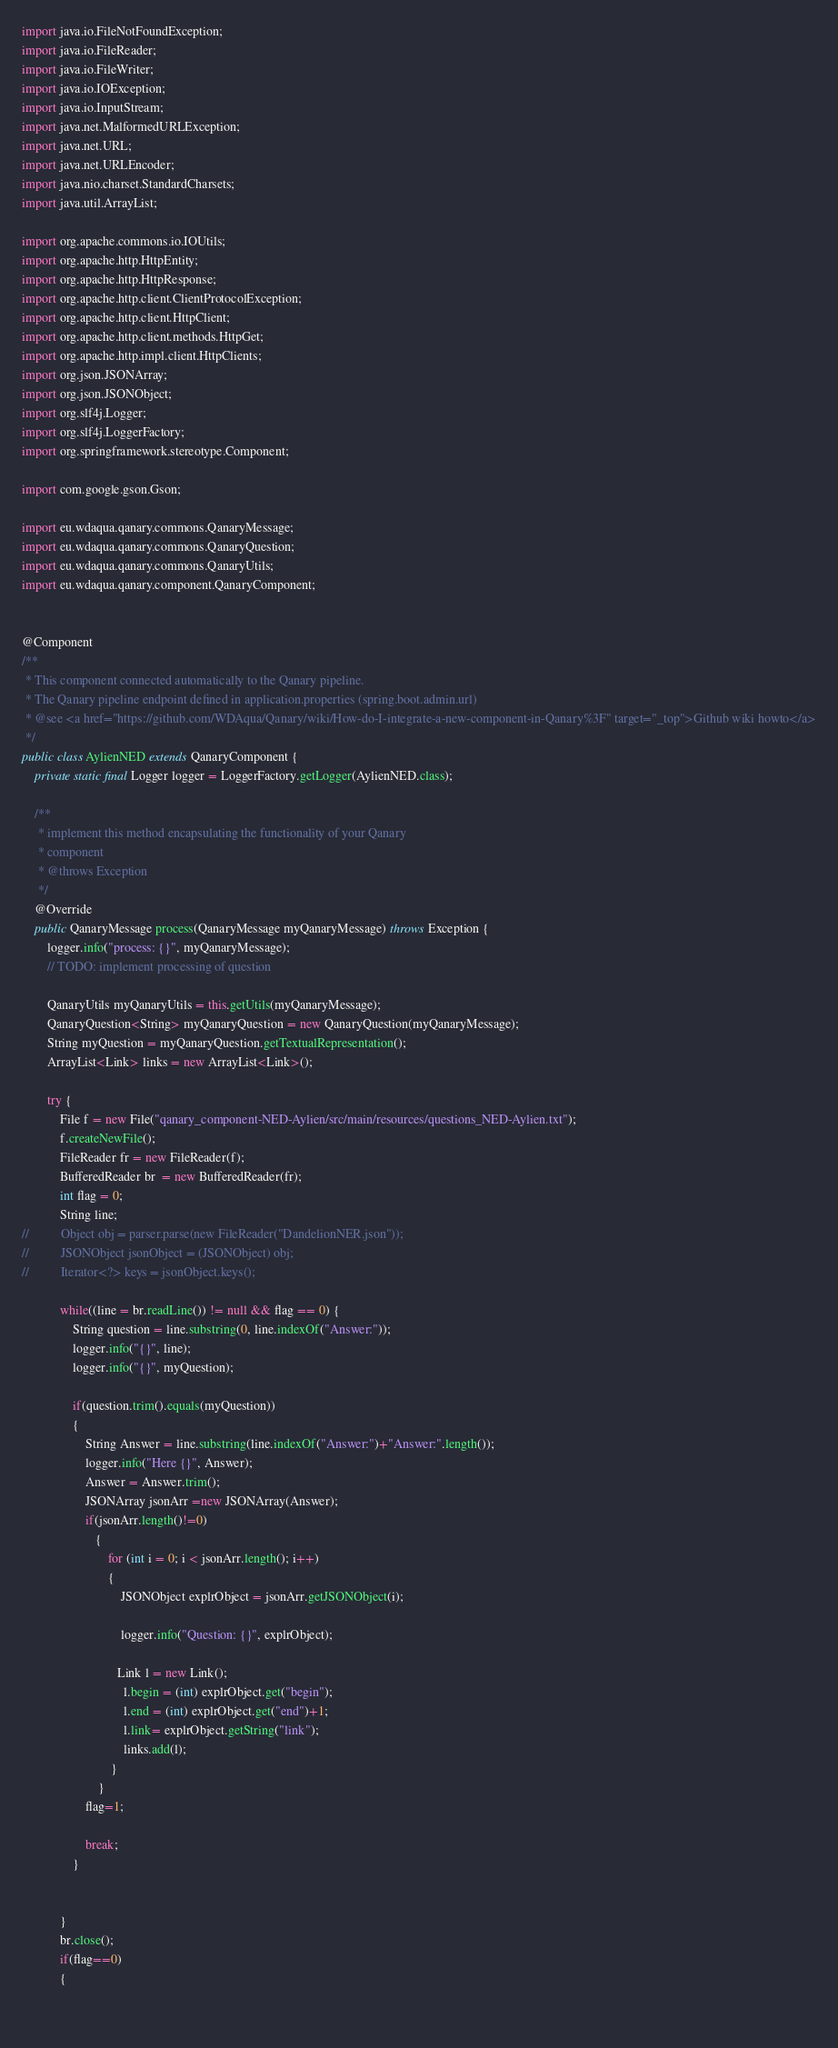<code> <loc_0><loc_0><loc_500><loc_500><_Java_>import java.io.FileNotFoundException;
import java.io.FileReader;
import java.io.FileWriter;
import java.io.IOException;
import java.io.InputStream;
import java.net.MalformedURLException;
import java.net.URL;
import java.net.URLEncoder;
import java.nio.charset.StandardCharsets;
import java.util.ArrayList;

import org.apache.commons.io.IOUtils;
import org.apache.http.HttpEntity;
import org.apache.http.HttpResponse;
import org.apache.http.client.ClientProtocolException;
import org.apache.http.client.HttpClient;
import org.apache.http.client.methods.HttpGet;
import org.apache.http.impl.client.HttpClients;
import org.json.JSONArray;
import org.json.JSONObject;
import org.slf4j.Logger;
import org.slf4j.LoggerFactory;
import org.springframework.stereotype.Component;

import com.google.gson.Gson;

import eu.wdaqua.qanary.commons.QanaryMessage;
import eu.wdaqua.qanary.commons.QanaryQuestion;
import eu.wdaqua.qanary.commons.QanaryUtils;
import eu.wdaqua.qanary.component.QanaryComponent;


@Component
/**
 * This component connected automatically to the Qanary pipeline.
 * The Qanary pipeline endpoint defined in application.properties (spring.boot.admin.url)
 * @see <a href="https://github.com/WDAqua/Qanary/wiki/How-do-I-integrate-a-new-component-in-Qanary%3F" target="_top">Github wiki howto</a>
 */
public class AylienNED extends QanaryComponent {
	private static final Logger logger = LoggerFactory.getLogger(AylienNED.class);

	/**
	 * implement this method encapsulating the functionality of your Qanary
	 * component
	 * @throws Exception 
	 */
	@Override
	public QanaryMessage process(QanaryMessage myQanaryMessage) throws Exception {
		logger.info("process: {}", myQanaryMessage);
		// TODO: implement processing of question
		
		QanaryUtils myQanaryUtils = this.getUtils(myQanaryMessage);
	    QanaryQuestion<String> myQanaryQuestion = new QanaryQuestion(myQanaryMessage);
	    String myQuestion = myQanaryQuestion.getTextualRepresentation();
	    ArrayList<Link> links = new ArrayList<Link>();
	    
	    try {
			File f = new File("qanary_component-NED-Aylien/src/main/resources/questions_NED-Aylien.txt");
			f.createNewFile(); 
	    	FileReader fr = new FileReader(f);
	    	BufferedReader br  = new BufferedReader(fr);
			int flag = 0;
			String line;
//			Object obj = parser.parse(new FileReader("DandelionNER.json"));
//			JSONObject jsonObject = (JSONObject) obj;
//			Iterator<?> keys = jsonObject.keys();
			
			while((line = br.readLine()) != null && flag == 0) {
			    String question = line.substring(0, line.indexOf("Answer:"));
				logger.info("{}", line);
				logger.info("{}", myQuestion);
				
			    if(question.trim().equals(myQuestion))
			    {
			    	String Answer = line.substring(line.indexOf("Answer:")+"Answer:".length());
			    	logger.info("Here {}", Answer);
			    	Answer = Answer.trim();
			    	JSONArray jsonArr =new JSONArray(Answer);
			    	if(jsonArr.length()!=0)
	 	        	   {
	 	        		   for (int i = 0; i < jsonArr.length(); i++) 
	 	        		   {
	 	        			   JSONObject explrObject = jsonArr.getJSONObject(i);
	 	        			  
	 	        			   logger.info("Question: {}", explrObject);
	 	        			   
	 	        			  Link l = new Link();
		    	                l.begin = (int) explrObject.get("begin");
		    	                l.end = (int) explrObject.get("end")+1;
		    	                l.link= explrObject.getString("link");
		    	                links.add(l);
		            		}
		            	}
			    	flag=1;
			    	
			    	break;	
			    }
			   
			    
			}
			br.close();
			if(flag==0)
			{
	    
	    </code> 